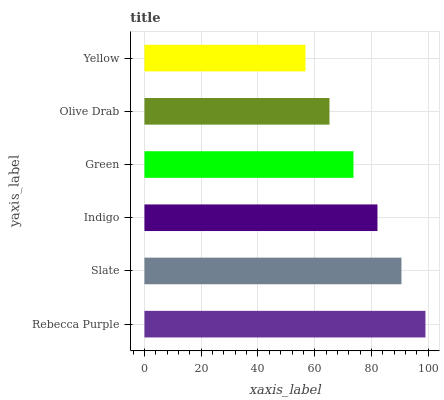Is Yellow the minimum?
Answer yes or no. Yes. Is Rebecca Purple the maximum?
Answer yes or no. Yes. Is Slate the minimum?
Answer yes or no. No. Is Slate the maximum?
Answer yes or no. No. Is Rebecca Purple greater than Slate?
Answer yes or no. Yes. Is Slate less than Rebecca Purple?
Answer yes or no. Yes. Is Slate greater than Rebecca Purple?
Answer yes or no. No. Is Rebecca Purple less than Slate?
Answer yes or no. No. Is Indigo the high median?
Answer yes or no. Yes. Is Green the low median?
Answer yes or no. Yes. Is Slate the high median?
Answer yes or no. No. Is Yellow the low median?
Answer yes or no. No. 